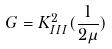<formula> <loc_0><loc_0><loc_500><loc_500>G = K _ { I I I } ^ { 2 } ( \frac { 1 } { 2 \mu } )</formula> 